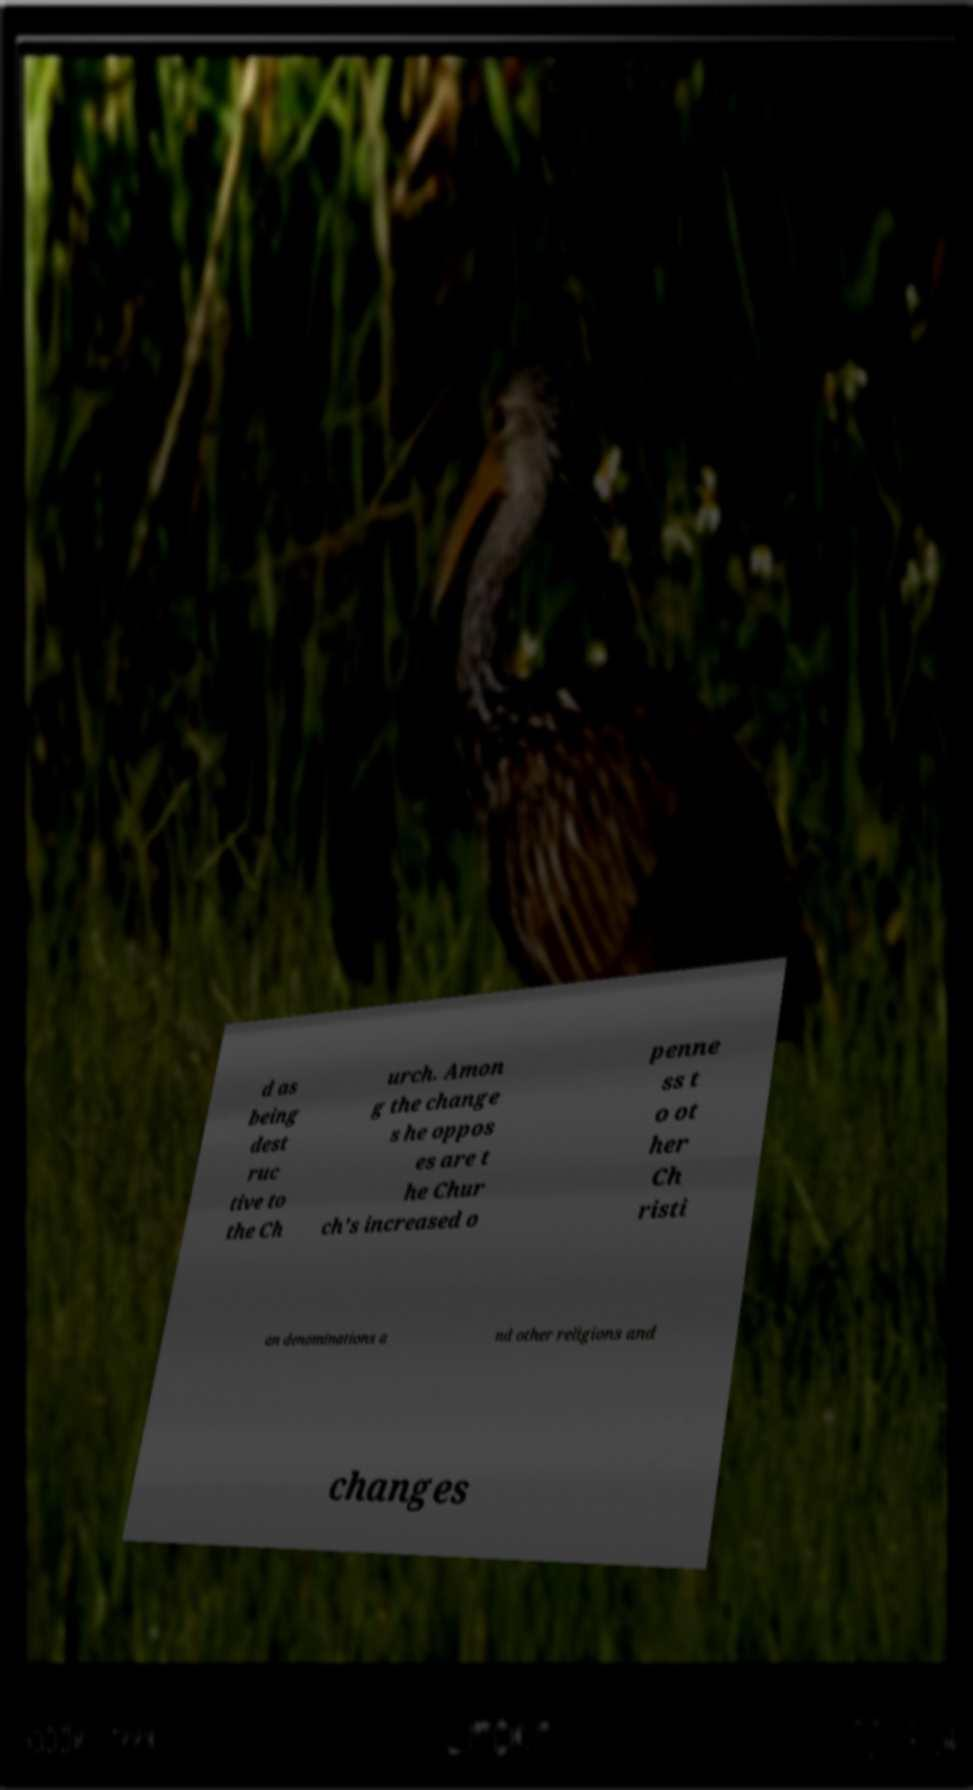Please identify and transcribe the text found in this image. d as being dest ruc tive to the Ch urch. Amon g the change s he oppos es are t he Chur ch's increased o penne ss t o ot her Ch risti an denominations a nd other religions and changes 